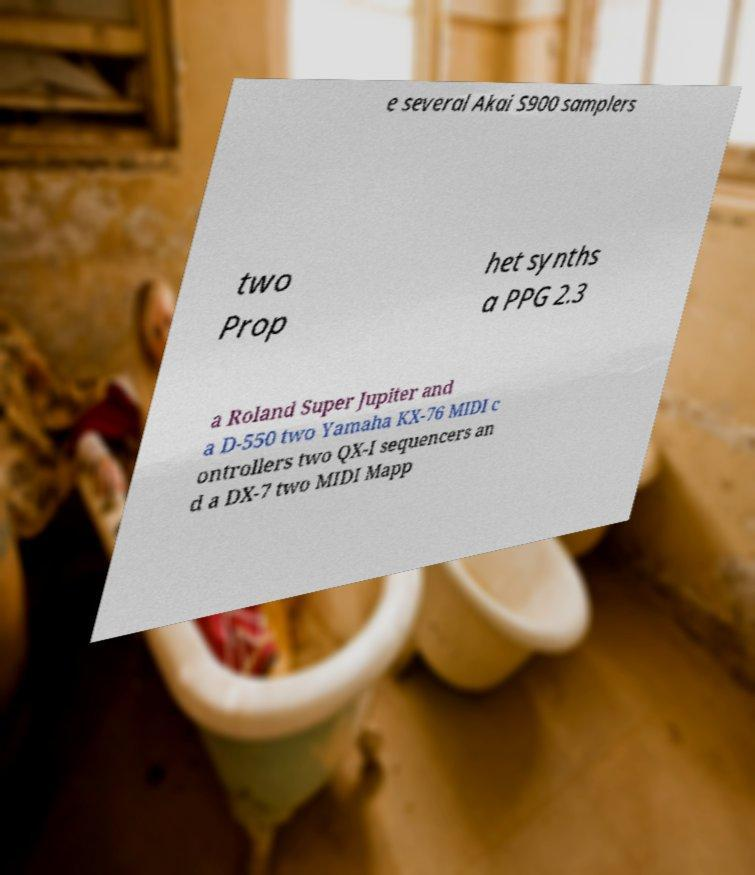I need the written content from this picture converted into text. Can you do that? e several Akai S900 samplers two Prop het synths a PPG 2.3 a Roland Super Jupiter and a D-550 two Yamaha KX-76 MIDI c ontrollers two QX-I sequencers an d a DX-7 two MIDI Mapp 